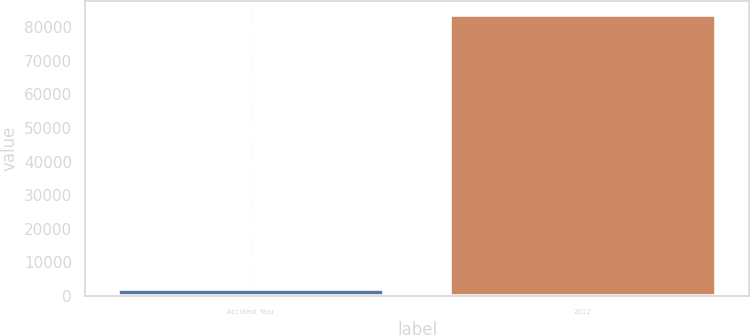Convert chart to OTSL. <chart><loc_0><loc_0><loc_500><loc_500><bar_chart><fcel>Accident Year<fcel>2012<nl><fcel>2013<fcel>83766<nl></chart> 